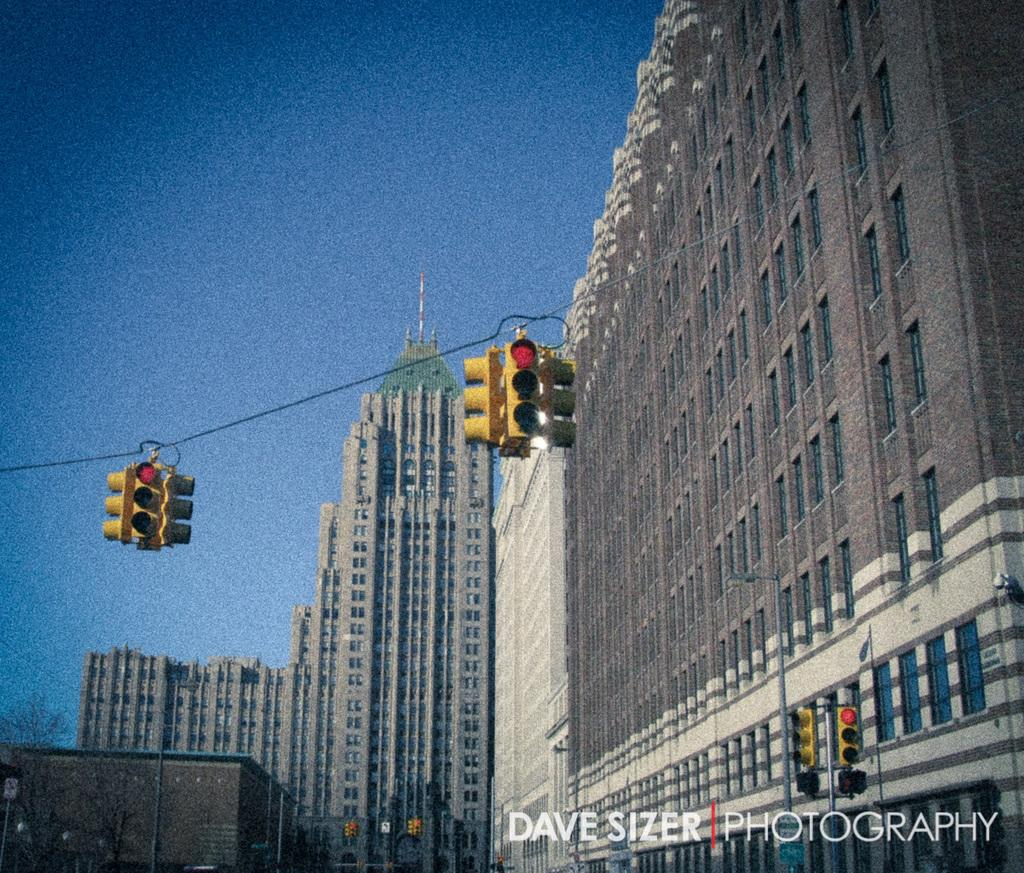What type of infrastructure is present in the image? There are traffic lights, poles, and buildings in the image. Can you describe the traffic lights in the image? The traffic lights are used to control the flow of traffic. What else can be seen on the poles besides the traffic lights? The provided facts do not mention anything else on the poles. What type of structures are depicted in the image? The image contains buildings. What word is written on the seat in the image? There is no seat present in the image, so it is not possible to answer that question. 